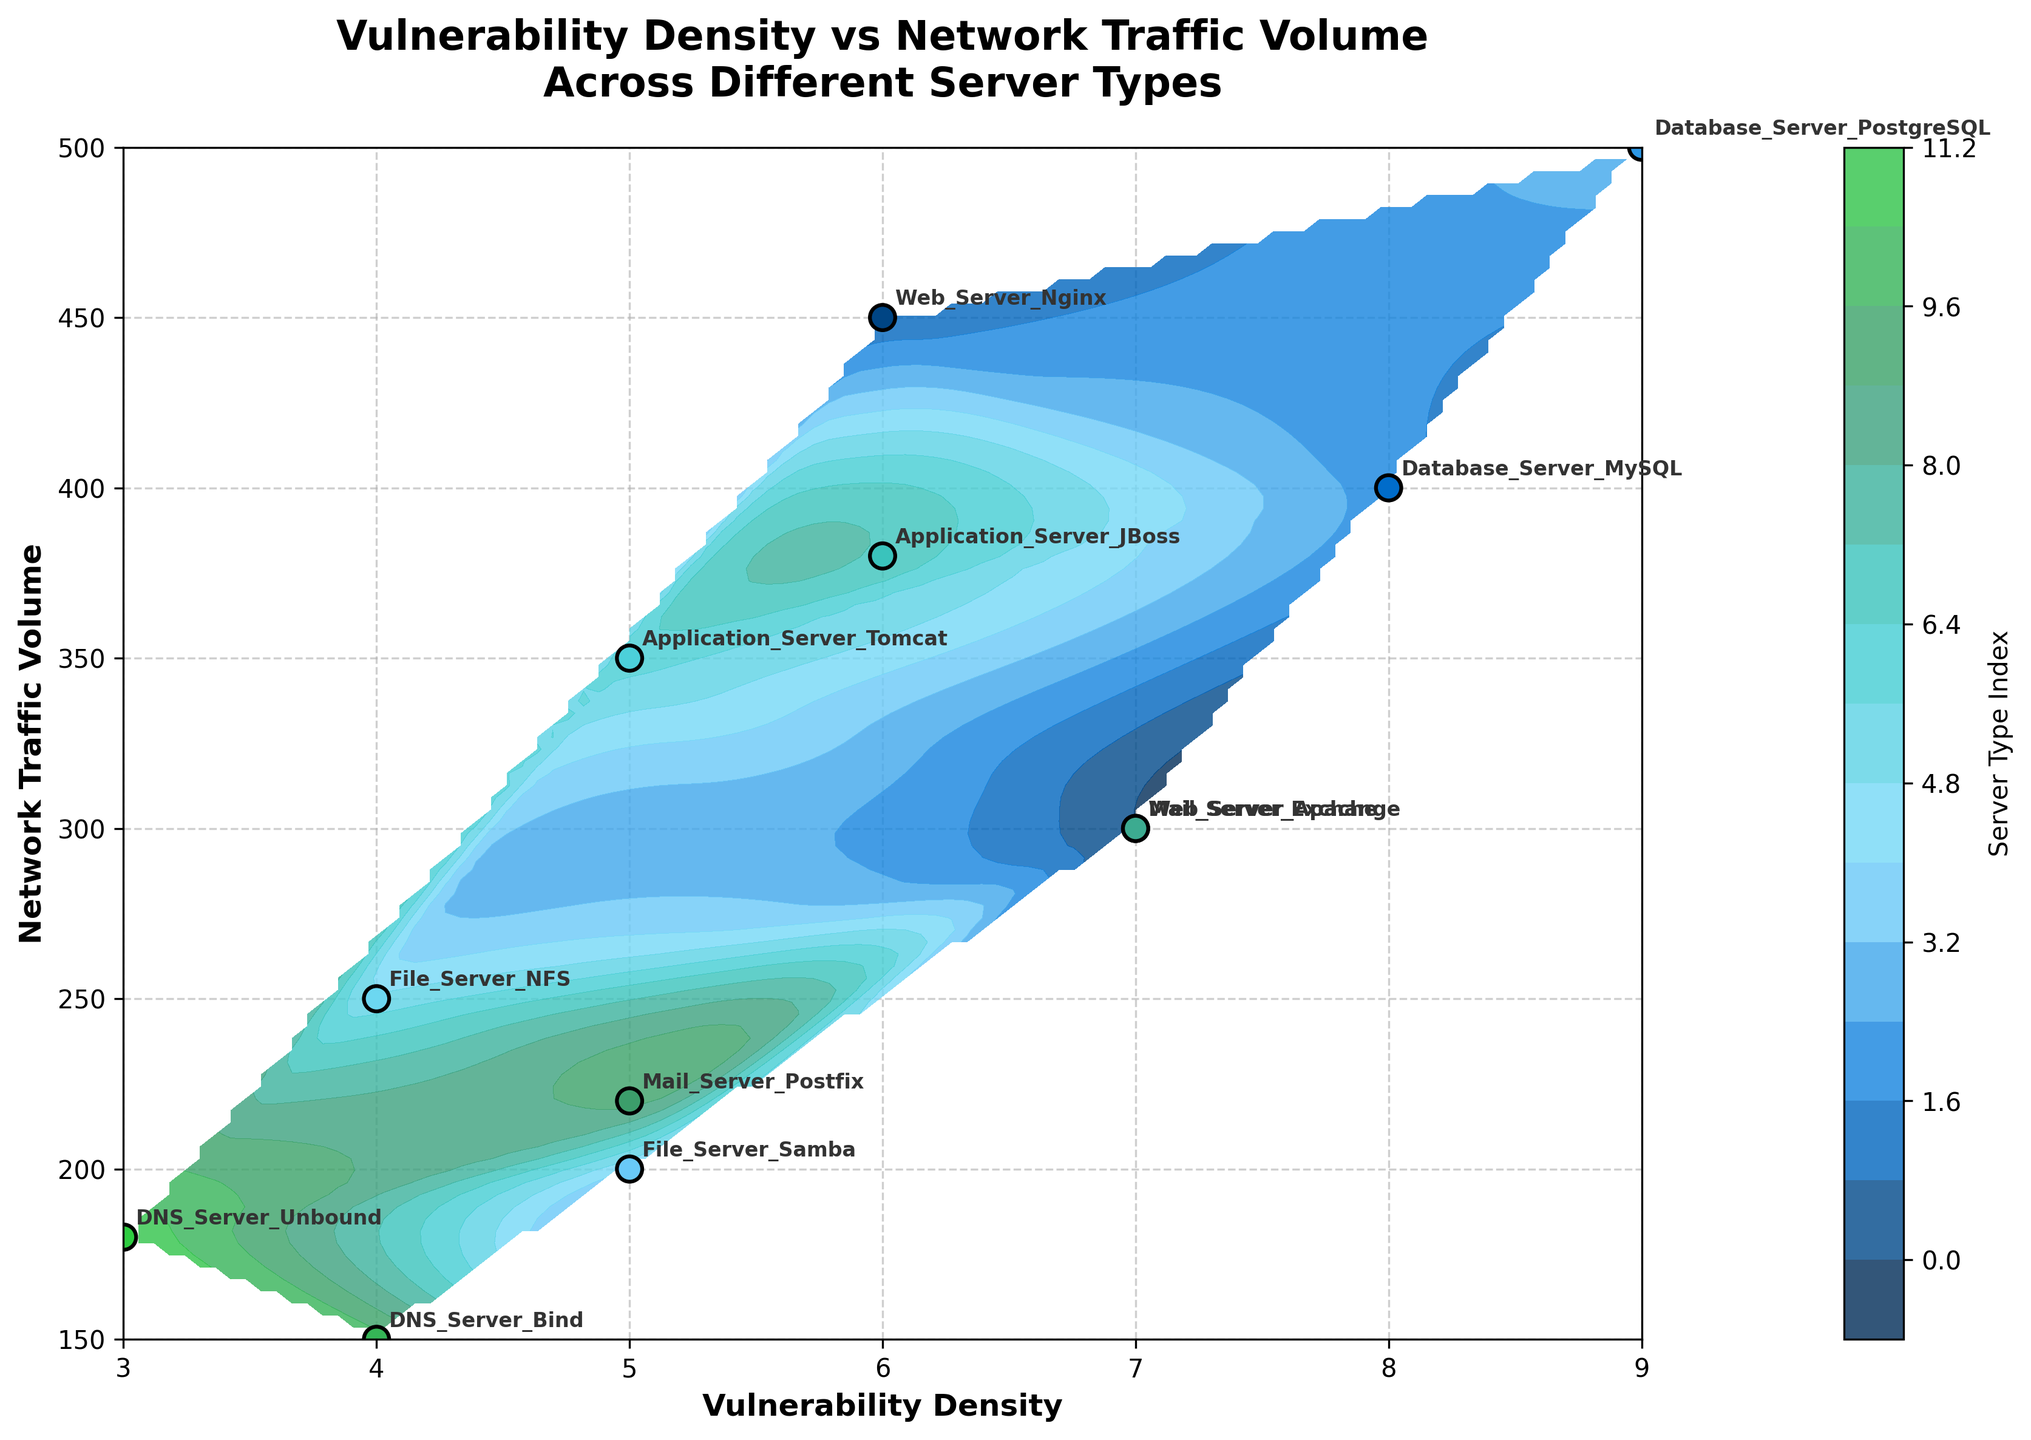What is the title of the figure? The title of the figure is usually displayed at the top of the plot. In this case, it is given in the code as 'Vulnerability Density vs Network Traffic Volume Across Different Server Types'.
Answer: Vulnerability Density vs Network Traffic Volume Across Different Server Types What are the labels on the x-axis and y-axis? The x-axis and y-axis labels provide the scales of measurement. According to the code, the x-axis is labeled 'Vulnerability Density' and the y-axis is labeled 'Network Traffic Volume'.
Answer: Vulnerability Density (x-axis), Network Traffic Volume (y-axis) How many server types are visualized on the plot? Each server type is represented by a unique point on the plot. Counting the number of different 'Server_Type' entries in the corresponding data or annotations, there are 12 server types displayed.
Answer: 12 Which server type has the highest vulnerability density? Find the point on the plot corresponding to the highest value on the x-axis (Vulnerability Density) and check its label. According to the data, the highest vulnerability density is 9, belonging to Database_Server_PostgreSQL.
Answer: Database_Server_PostgreSQL What's the range of network traffic volume visualized in the plot? The range is the difference between the maximum and minimum values of the network traffic volume. The minimum value is 150 (DNS_Server_Bind) and the maximum is 500 (Database_Server_PostgreSQL), giving a range of 350.
Answer: 350 Which server type has the lowest network traffic volume and its vulnerability density? Locate the server type with the smallest y-axis value (Network Traffic Volume). This is DNS_Server_Bind with a network traffic volume of 150 and a vulnerability density of 4.
Answer: DNS_Server_Bind with vulnerability density 4 What are the server types with a vulnerability density equal to 5? Identify all points on the plot where the x-axis value (Vulnerability Density) is equal to 5 and check their labels. These are File_Server_Samba, Application_Server_Tomcat, and Mail_Server_Postfix.
Answer: File_Server_Samba, Application_Server_Tomcat, Mail_Server_Postfix Compare the network traffic volumes between Web_Server_Apache and Web_Server_Nginx. Which one is greater? By checking the y-axis values for these two points, Web_Server_Apache has a network traffic volume of 300, whereas Web_Server_Nginx has 450. Hence, Web_Server_Nginx has a greater network traffic volume.
Answer: Web_Server_Nginx Which server types are clustered around a network traffic volume of 300? Identify points whose y-values are around 300. These include Web_Server_Apache (300), Mail_Server_Exchange (300), and Application_Server_Tomcat (350), which is close to 300.
Answer: Web_Server_Apache, Mail_Server_Exchange, Application_Server_Tomcat (close to 300) What's the median vulnerability density value of the server types? Arrange the vulnerability densities in ascending order (3, 4, 4, 5, 5, 5, 6, 6, 7, 7, 8, 9). The middle values are 5 and 6, so the median is (5 + 6) / 2 = 5.5.
Answer: 5.5 